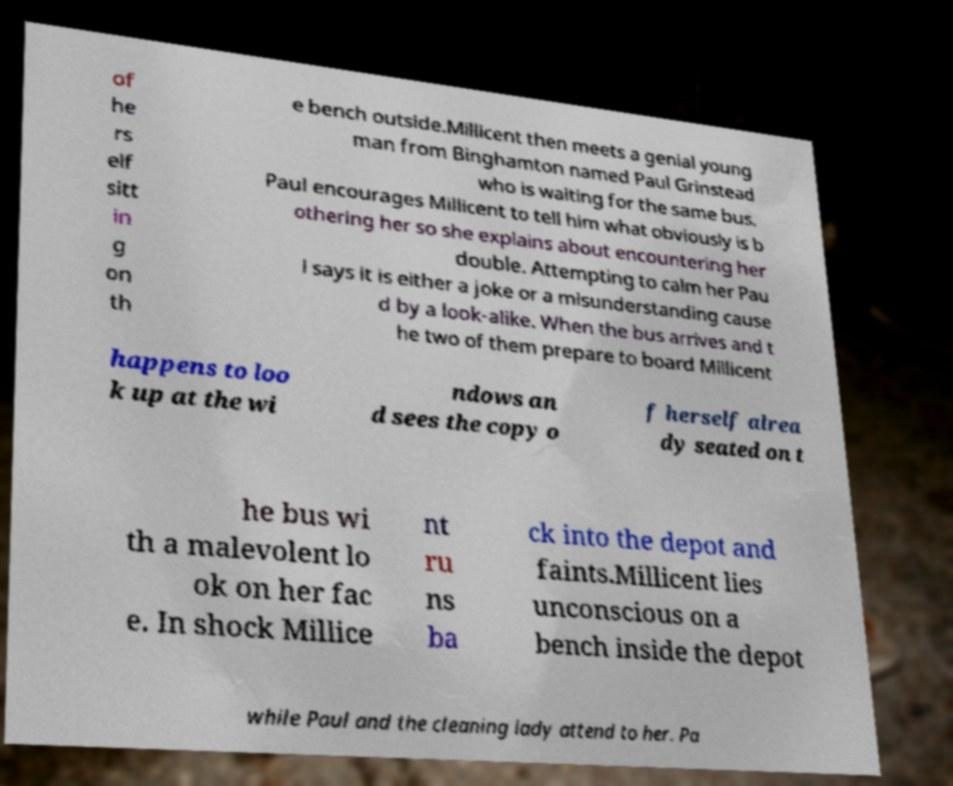There's text embedded in this image that I need extracted. Can you transcribe it verbatim? of he rs elf sitt in g on th e bench outside.Millicent then meets a genial young man from Binghamton named Paul Grinstead who is waiting for the same bus. Paul encourages Millicent to tell him what obviously is b othering her so she explains about encountering her double. Attempting to calm her Pau l says it is either a joke or a misunderstanding cause d by a look-alike. When the bus arrives and t he two of them prepare to board Millicent happens to loo k up at the wi ndows an d sees the copy o f herself alrea dy seated on t he bus wi th a malevolent lo ok on her fac e. In shock Millice nt ru ns ba ck into the depot and faints.Millicent lies unconscious on a bench inside the depot while Paul and the cleaning lady attend to her. Pa 